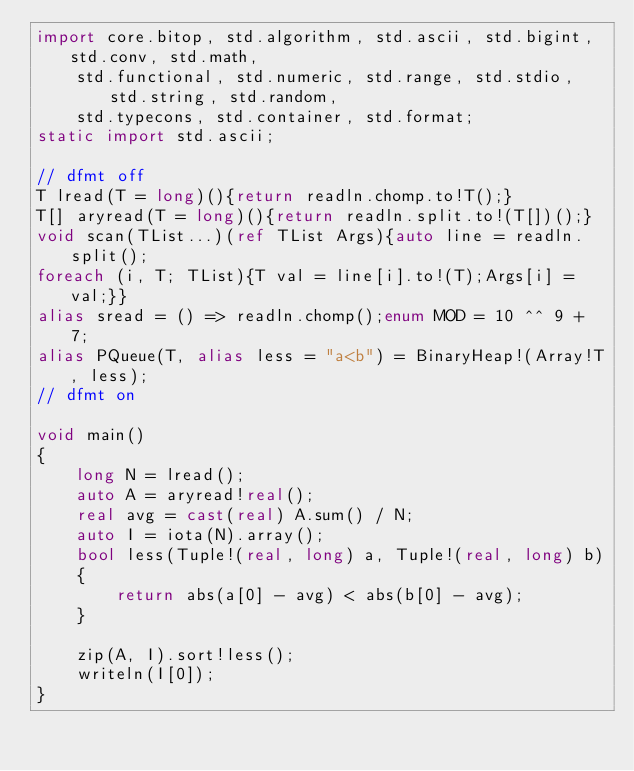<code> <loc_0><loc_0><loc_500><loc_500><_D_>import core.bitop, std.algorithm, std.ascii, std.bigint, std.conv, std.math,
    std.functional, std.numeric, std.range, std.stdio, std.string, std.random,
    std.typecons, std.container, std.format;
static import std.ascii;

// dfmt off
T lread(T = long)(){return readln.chomp.to!T();}
T[] aryread(T = long)(){return readln.split.to!(T[])();}
void scan(TList...)(ref TList Args){auto line = readln.split();
foreach (i, T; TList){T val = line[i].to!(T);Args[i] = val;}}
alias sread = () => readln.chomp();enum MOD = 10 ^^ 9 + 7;
alias PQueue(T, alias less = "a<b") = BinaryHeap!(Array!T, less);
// dfmt on

void main()
{
    long N = lread();
    auto A = aryread!real();
    real avg = cast(real) A.sum() / N;
    auto I = iota(N).array();
    bool less(Tuple!(real, long) a, Tuple!(real, long) b)
    {
        return abs(a[0] - avg) < abs(b[0] - avg);
    }

    zip(A, I).sort!less();
    writeln(I[0]);
}
</code> 